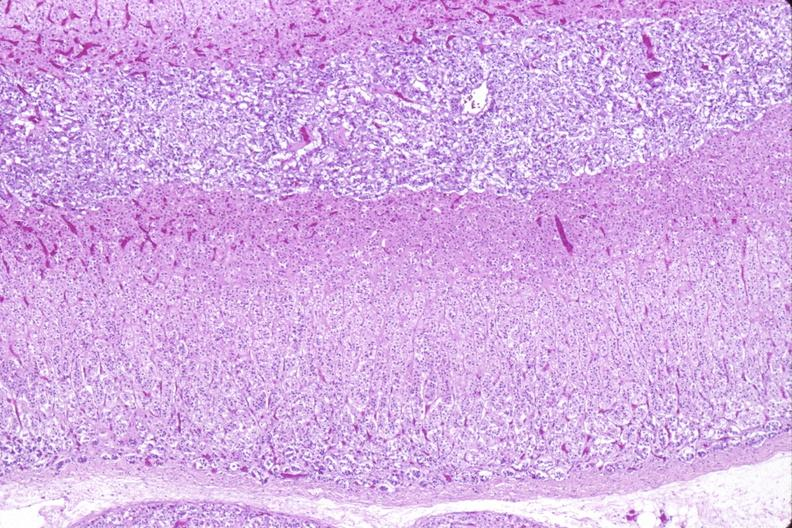what does this image show?
Answer the question using a single word or phrase. Adrenal gland 